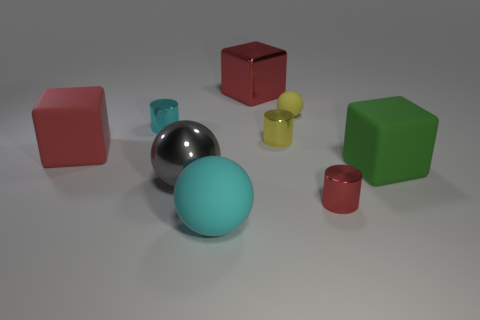Add 1 big red matte blocks. How many objects exist? 10 Subtract all blocks. How many objects are left? 6 Add 7 metal cubes. How many metal cubes exist? 8 Subtract 0 brown cubes. How many objects are left? 9 Subtract all large green cubes. Subtract all big red metal cubes. How many objects are left? 7 Add 3 yellow objects. How many yellow objects are left? 5 